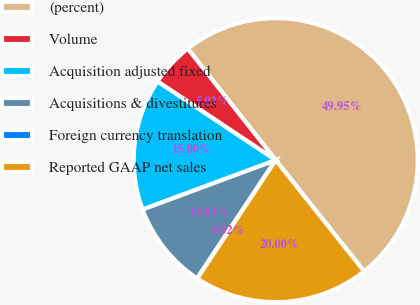Convert chart. <chart><loc_0><loc_0><loc_500><loc_500><pie_chart><fcel>(percent)<fcel>Volume<fcel>Acquisition adjusted fixed<fcel>Acquisitions & divestitures<fcel>Foreign currency translation<fcel>Reported GAAP net sales<nl><fcel>49.95%<fcel>5.02%<fcel>15.0%<fcel>10.01%<fcel>0.02%<fcel>20.0%<nl></chart> 